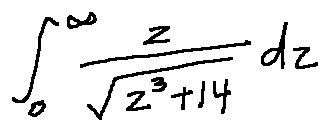<formula> <loc_0><loc_0><loc_500><loc_500>\int \lim i t s _ { 0 } ^ { \infty } \frac { z } { \sqrt { z ^ { 3 } + 1 4 } } d z</formula> 